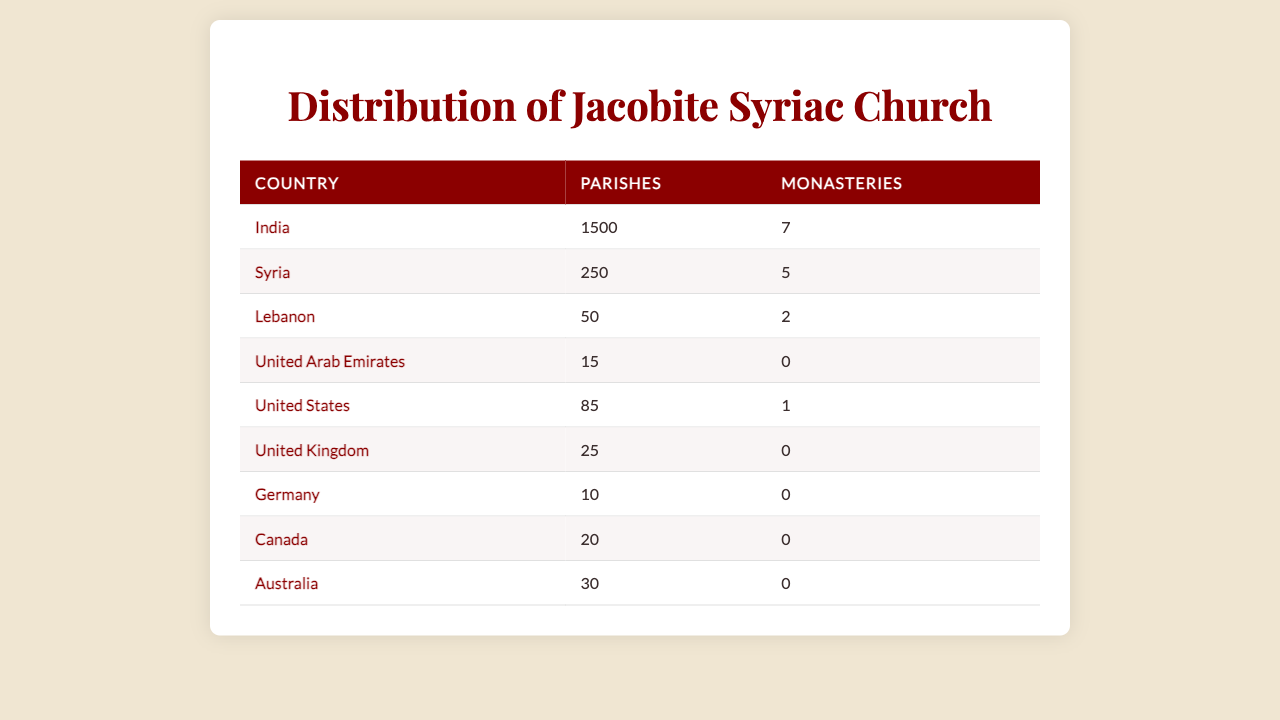What is the total number of parishes in all countries listed? To find the total number of parishes, we sum the values of parishes across all countries: 1500 (India) + 250 (Syria) + 50 (Lebanon) + 15 (UAE) + 85 (USA) + 25 (UK) + 10 (Germany) + 20 (Canada) + 30 (Australia) = 1965.
Answer: 1965 Which country has the highest number of monasteries? By examining the monasteries' counts in the table, India has 7 monasteries, which is higher than any other country listed.
Answer: India Are there any countries in the table without monasteries? Yes, by reviewing the monastery counts, the United Arab Emirates, United Kingdom, Germany, Canada, and Australia all have 0 monasteries.
Answer: Yes What is the average number of parishes per country? To calculate the average, sum the parishes (1965 as previously calculated) and divide by the number of countries (9): 1965 / 9 ≈ 218.33.
Answer: 218.33 How many more parishes does India have compared to Lebanon? India has 1500 parishes and Lebanon has 50 parishes. The difference is 1500 - 50 = 1450.
Answer: 1450 Is it true that Syria has more parishes than the United States? Syria has 250 parishes, and the United States has 85 parishes. Since 250 > 85, the statement is true.
Answer: Yes What percentage of the total parishes are located in India? India has 1500 parishes out of a total of 1965. The percentage is (1500 / 1965) * 100 ≈ 76.3%.
Answer: 76.3% Which countries together have the least number of parishes? The countries with the least parishes are the United Kingdom (25), Germany (10), Canada (20), UAE (15), and Australia (30). Summing these gives 25 + 10 + 20 + 15 + 30 = 100.
Answer: 100 If we combined the number of parishes in Canada and Australia, would that exceed the number of parishes in Lebanon? Canada has 20 parishes and Australia has 30, totaling 20 + 30 = 50, which is less than Lebanon's 50 parishes.
Answer: No Is there a country that has more monasteries than the number of parishes in the United States? The United States has 85 parishes and only 1 monastery. No country listed has more than 1 monastery, meaning no country exceeds the United States' parishes in this regard.
Answer: No 